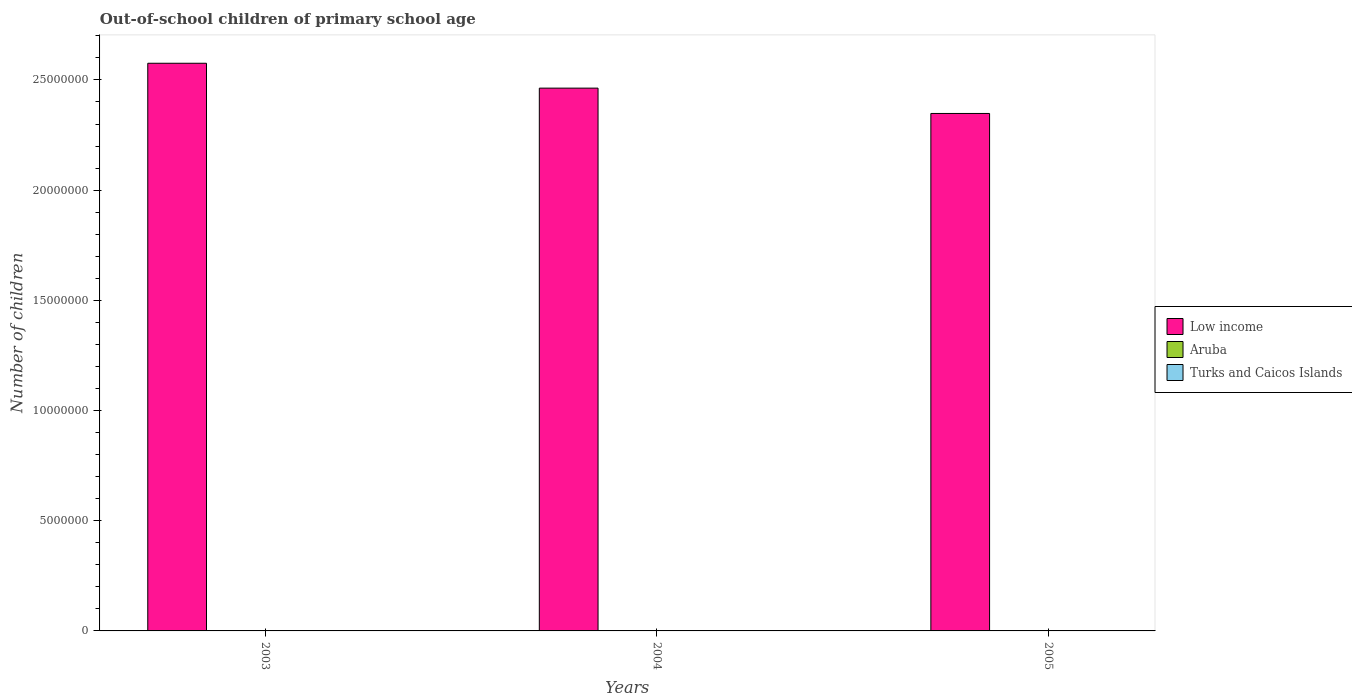Are the number of bars on each tick of the X-axis equal?
Keep it short and to the point. Yes. What is the label of the 1st group of bars from the left?
Offer a terse response. 2003. What is the number of out-of-school children in Aruba in 2004?
Keep it short and to the point. 480. Across all years, what is the maximum number of out-of-school children in Turks and Caicos Islands?
Provide a short and direct response. 532. Across all years, what is the minimum number of out-of-school children in Aruba?
Provide a short and direct response. 186. In which year was the number of out-of-school children in Aruba maximum?
Your answer should be compact. 2003. What is the total number of out-of-school children in Low income in the graph?
Keep it short and to the point. 7.39e+07. What is the difference between the number of out-of-school children in Aruba in 2003 and that in 2004?
Keep it short and to the point. 66. What is the difference between the number of out-of-school children in Aruba in 2005 and the number of out-of-school children in Low income in 2003?
Provide a succinct answer. -2.58e+07. What is the average number of out-of-school children in Aruba per year?
Keep it short and to the point. 404. In the year 2004, what is the difference between the number of out-of-school children in Low income and number of out-of-school children in Aruba?
Your answer should be compact. 2.46e+07. In how many years, is the number of out-of-school children in Aruba greater than 10000000?
Your response must be concise. 0. What is the ratio of the number of out-of-school children in Turks and Caicos Islands in 2003 to that in 2004?
Offer a terse response. 1.51. Is the number of out-of-school children in Turks and Caicos Islands in 2004 less than that in 2005?
Give a very brief answer. Yes. What is the difference between the highest and the second highest number of out-of-school children in Aruba?
Give a very brief answer. 66. What is the difference between the highest and the lowest number of out-of-school children in Low income?
Keep it short and to the point. 2.28e+06. In how many years, is the number of out-of-school children in Aruba greater than the average number of out-of-school children in Aruba taken over all years?
Offer a very short reply. 2. What does the 2nd bar from the left in 2004 represents?
Make the answer very short. Aruba. How many bars are there?
Offer a terse response. 9. What is the difference between two consecutive major ticks on the Y-axis?
Your response must be concise. 5.00e+06. Are the values on the major ticks of Y-axis written in scientific E-notation?
Offer a very short reply. No. How are the legend labels stacked?
Keep it short and to the point. Vertical. What is the title of the graph?
Make the answer very short. Out-of-school children of primary school age. Does "Philippines" appear as one of the legend labels in the graph?
Ensure brevity in your answer.  No. What is the label or title of the Y-axis?
Offer a terse response. Number of children. What is the Number of children in Low income in 2003?
Offer a very short reply. 2.58e+07. What is the Number of children in Aruba in 2003?
Your response must be concise. 546. What is the Number of children in Turks and Caicos Islands in 2003?
Your answer should be compact. 532. What is the Number of children in Low income in 2004?
Provide a short and direct response. 2.46e+07. What is the Number of children of Aruba in 2004?
Give a very brief answer. 480. What is the Number of children of Turks and Caicos Islands in 2004?
Ensure brevity in your answer.  353. What is the Number of children in Low income in 2005?
Make the answer very short. 2.35e+07. What is the Number of children in Aruba in 2005?
Provide a succinct answer. 186. What is the Number of children in Turks and Caicos Islands in 2005?
Give a very brief answer. 477. Across all years, what is the maximum Number of children in Low income?
Keep it short and to the point. 2.58e+07. Across all years, what is the maximum Number of children in Aruba?
Your response must be concise. 546. Across all years, what is the maximum Number of children in Turks and Caicos Islands?
Your answer should be compact. 532. Across all years, what is the minimum Number of children in Low income?
Give a very brief answer. 2.35e+07. Across all years, what is the minimum Number of children of Aruba?
Make the answer very short. 186. Across all years, what is the minimum Number of children in Turks and Caicos Islands?
Offer a very short reply. 353. What is the total Number of children of Low income in the graph?
Offer a terse response. 7.39e+07. What is the total Number of children in Aruba in the graph?
Provide a short and direct response. 1212. What is the total Number of children of Turks and Caicos Islands in the graph?
Make the answer very short. 1362. What is the difference between the Number of children in Low income in 2003 and that in 2004?
Your answer should be very brief. 1.13e+06. What is the difference between the Number of children in Aruba in 2003 and that in 2004?
Your answer should be compact. 66. What is the difference between the Number of children of Turks and Caicos Islands in 2003 and that in 2004?
Give a very brief answer. 179. What is the difference between the Number of children in Low income in 2003 and that in 2005?
Your answer should be very brief. 2.28e+06. What is the difference between the Number of children of Aruba in 2003 and that in 2005?
Ensure brevity in your answer.  360. What is the difference between the Number of children in Low income in 2004 and that in 2005?
Give a very brief answer. 1.15e+06. What is the difference between the Number of children of Aruba in 2004 and that in 2005?
Ensure brevity in your answer.  294. What is the difference between the Number of children of Turks and Caicos Islands in 2004 and that in 2005?
Your answer should be compact. -124. What is the difference between the Number of children in Low income in 2003 and the Number of children in Aruba in 2004?
Your answer should be very brief. 2.58e+07. What is the difference between the Number of children of Low income in 2003 and the Number of children of Turks and Caicos Islands in 2004?
Keep it short and to the point. 2.58e+07. What is the difference between the Number of children in Aruba in 2003 and the Number of children in Turks and Caicos Islands in 2004?
Offer a terse response. 193. What is the difference between the Number of children in Low income in 2003 and the Number of children in Aruba in 2005?
Provide a succinct answer. 2.58e+07. What is the difference between the Number of children of Low income in 2003 and the Number of children of Turks and Caicos Islands in 2005?
Give a very brief answer. 2.58e+07. What is the difference between the Number of children of Low income in 2004 and the Number of children of Aruba in 2005?
Provide a succinct answer. 2.46e+07. What is the difference between the Number of children in Low income in 2004 and the Number of children in Turks and Caicos Islands in 2005?
Offer a terse response. 2.46e+07. What is the difference between the Number of children of Aruba in 2004 and the Number of children of Turks and Caicos Islands in 2005?
Offer a very short reply. 3. What is the average Number of children in Low income per year?
Your answer should be very brief. 2.46e+07. What is the average Number of children of Aruba per year?
Keep it short and to the point. 404. What is the average Number of children of Turks and Caicos Islands per year?
Your answer should be compact. 454. In the year 2003, what is the difference between the Number of children in Low income and Number of children in Aruba?
Ensure brevity in your answer.  2.58e+07. In the year 2003, what is the difference between the Number of children in Low income and Number of children in Turks and Caicos Islands?
Your answer should be compact. 2.58e+07. In the year 2003, what is the difference between the Number of children of Aruba and Number of children of Turks and Caicos Islands?
Your answer should be compact. 14. In the year 2004, what is the difference between the Number of children in Low income and Number of children in Aruba?
Your answer should be very brief. 2.46e+07. In the year 2004, what is the difference between the Number of children of Low income and Number of children of Turks and Caicos Islands?
Your response must be concise. 2.46e+07. In the year 2004, what is the difference between the Number of children in Aruba and Number of children in Turks and Caicos Islands?
Your answer should be very brief. 127. In the year 2005, what is the difference between the Number of children in Low income and Number of children in Aruba?
Offer a very short reply. 2.35e+07. In the year 2005, what is the difference between the Number of children of Low income and Number of children of Turks and Caicos Islands?
Provide a succinct answer. 2.35e+07. In the year 2005, what is the difference between the Number of children of Aruba and Number of children of Turks and Caicos Islands?
Make the answer very short. -291. What is the ratio of the Number of children of Low income in 2003 to that in 2004?
Give a very brief answer. 1.05. What is the ratio of the Number of children in Aruba in 2003 to that in 2004?
Make the answer very short. 1.14. What is the ratio of the Number of children in Turks and Caicos Islands in 2003 to that in 2004?
Offer a terse response. 1.51. What is the ratio of the Number of children of Low income in 2003 to that in 2005?
Your answer should be compact. 1.1. What is the ratio of the Number of children of Aruba in 2003 to that in 2005?
Provide a short and direct response. 2.94. What is the ratio of the Number of children of Turks and Caicos Islands in 2003 to that in 2005?
Make the answer very short. 1.12. What is the ratio of the Number of children in Low income in 2004 to that in 2005?
Your answer should be compact. 1.05. What is the ratio of the Number of children of Aruba in 2004 to that in 2005?
Keep it short and to the point. 2.58. What is the ratio of the Number of children of Turks and Caicos Islands in 2004 to that in 2005?
Your answer should be very brief. 0.74. What is the difference between the highest and the second highest Number of children of Low income?
Your answer should be compact. 1.13e+06. What is the difference between the highest and the second highest Number of children in Aruba?
Your answer should be very brief. 66. What is the difference between the highest and the second highest Number of children in Turks and Caicos Islands?
Offer a terse response. 55. What is the difference between the highest and the lowest Number of children in Low income?
Your answer should be compact. 2.28e+06. What is the difference between the highest and the lowest Number of children in Aruba?
Provide a short and direct response. 360. What is the difference between the highest and the lowest Number of children of Turks and Caicos Islands?
Keep it short and to the point. 179. 